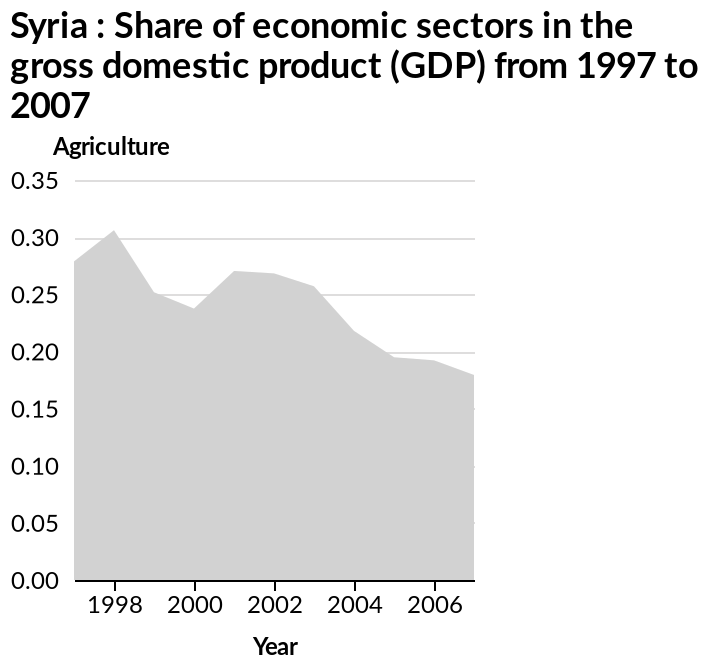<image>
What is the time span covered by the area diagram? The area diagram covers the years from 1997 to 2007. What was the share of economic sectors in 2007?  The share of economic sectors in 2007 was 0.175. Which economic sector is being represented in the diagram? The diagram represents the share of Agriculture in the gross domestic product (GDP) of Syria. Was there a period of greater economic sector share between 2001 and 2003? Yes, there was a period of greater economic sector share between 2001 and 2003. What does the x-axis represent in the diagram?  The x-axis represents the years from 1997 to 2007. 